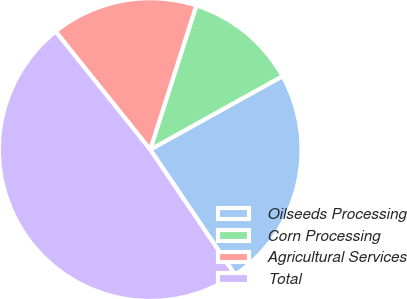Convert chart to OTSL. <chart><loc_0><loc_0><loc_500><loc_500><pie_chart><fcel>Oilseeds Processing<fcel>Corn Processing<fcel>Agricultural Services<fcel>Total<nl><fcel>23.59%<fcel>12.01%<fcel>15.68%<fcel>48.73%<nl></chart> 